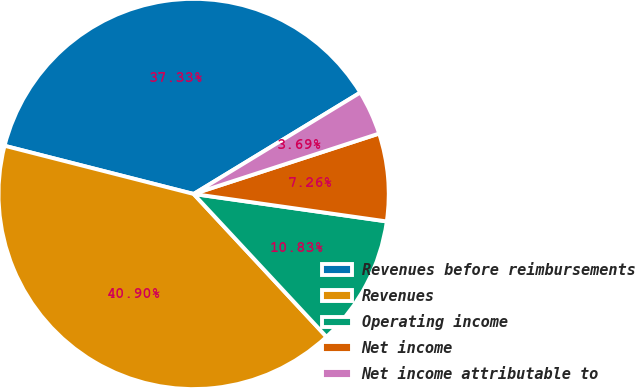<chart> <loc_0><loc_0><loc_500><loc_500><pie_chart><fcel>Revenues before reimbursements<fcel>Revenues<fcel>Operating income<fcel>Net income<fcel>Net income attributable to<nl><fcel>37.33%<fcel>40.9%<fcel>10.83%<fcel>7.26%<fcel>3.69%<nl></chart> 